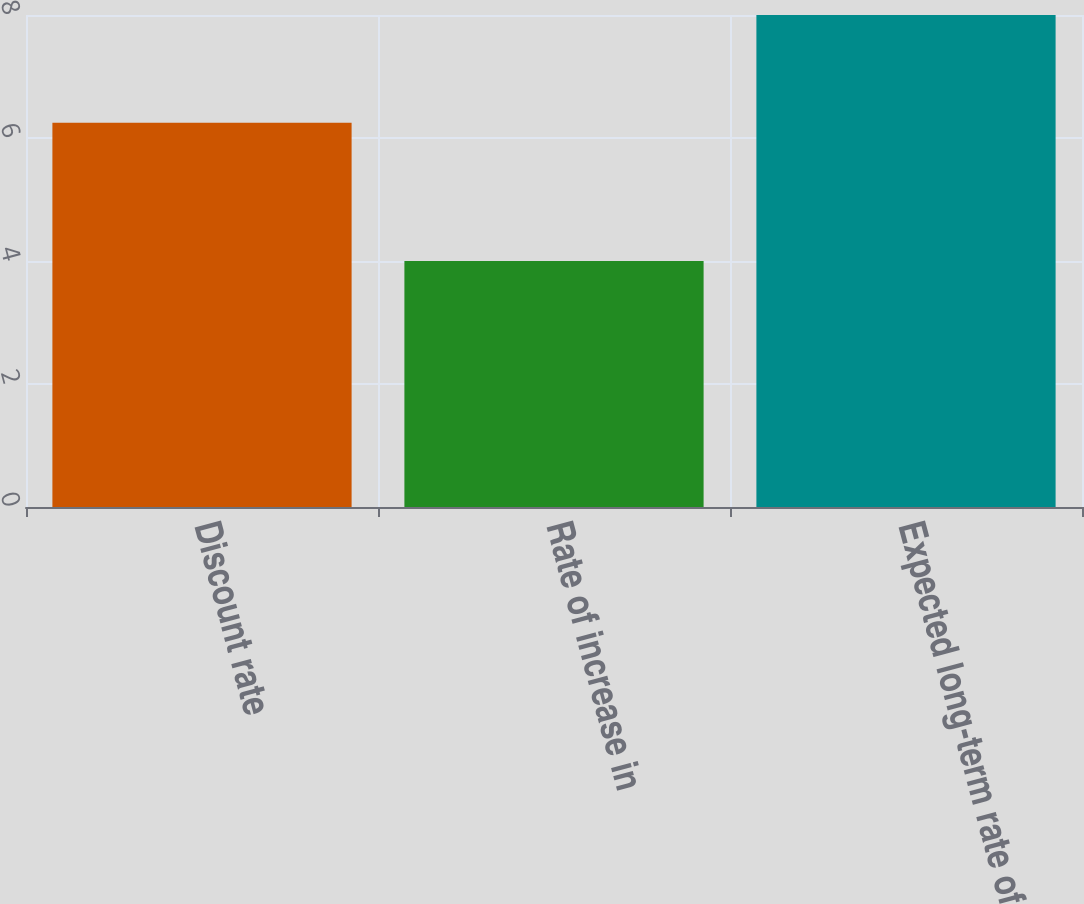<chart> <loc_0><loc_0><loc_500><loc_500><bar_chart><fcel>Discount rate<fcel>Rate of increase in<fcel>Expected long-term rate of<nl><fcel>6.25<fcel>4<fcel>8<nl></chart> 